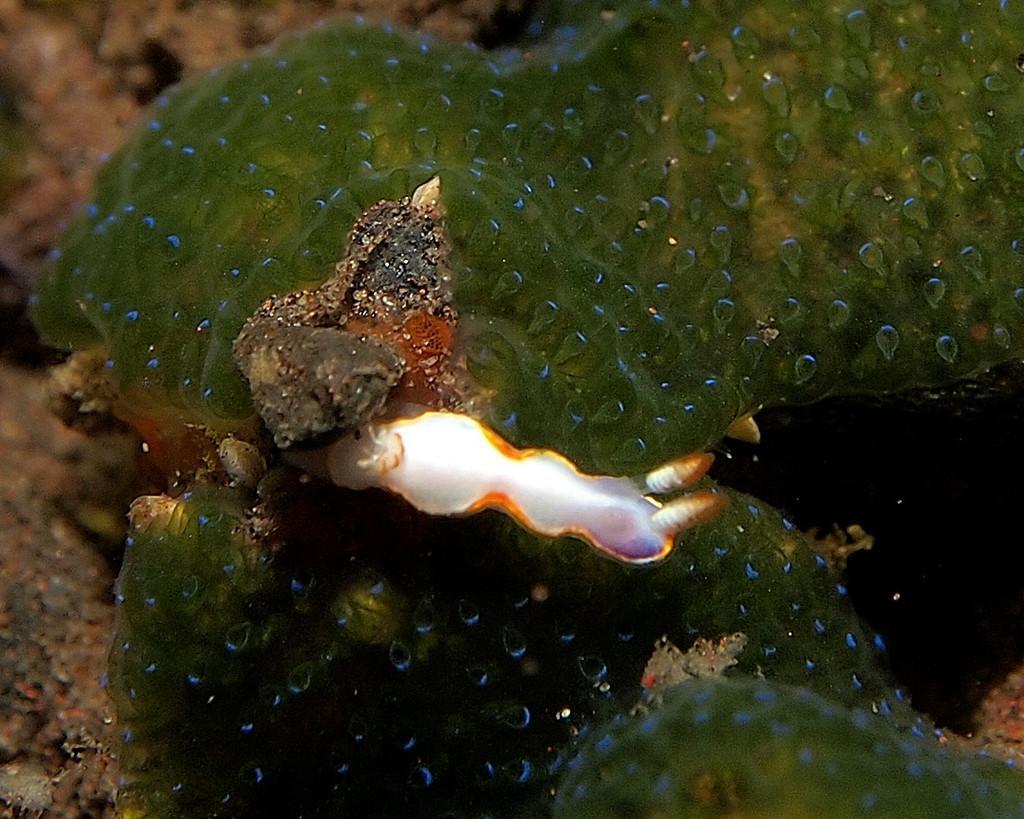How would you summarize this image in a sentence or two? In this image we can see a water animal. 